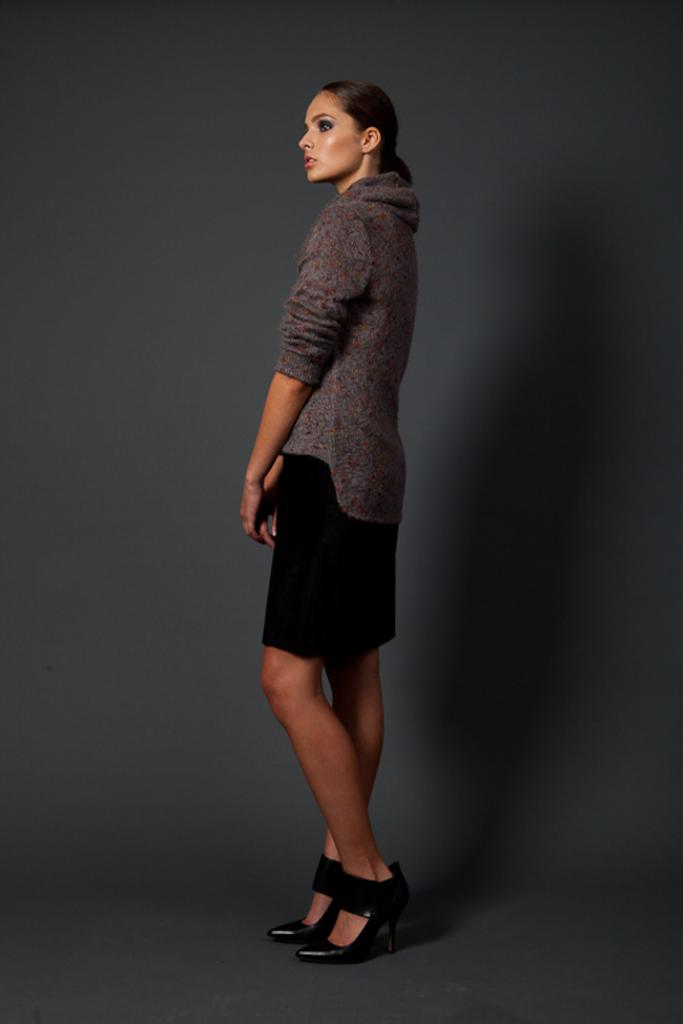Who is the main subject in the image? There is a woman in the image. What is the woman doing in the image? The woman is standing on the floor. Where is the woman located in the image? The woman is in the middle of the picture. What is the color of the background in the image? The background of the image is in grey color. What type of spark can be seen coming from the woman's hand in the image? There is no spark present in the image; the woman is simply standing on the floor. 